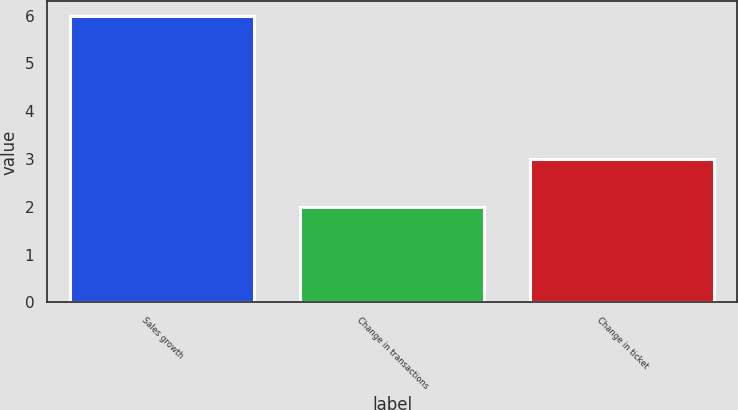Convert chart to OTSL. <chart><loc_0><loc_0><loc_500><loc_500><bar_chart><fcel>Sales growth<fcel>Change in transactions<fcel>Change in ticket<nl><fcel>6<fcel>2<fcel>3<nl></chart> 